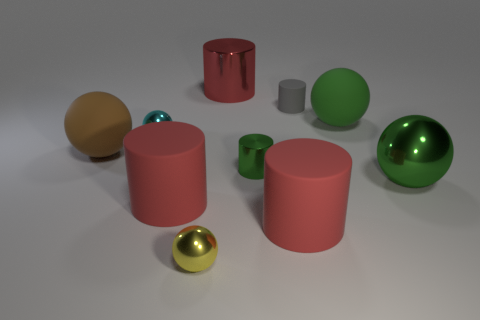How many cyan things are either tiny cylinders or metal balls?
Give a very brief answer. 1. Is the yellow shiny object the same shape as the tiny gray matte thing?
Offer a terse response. No. There is a large rubber cylinder that is to the left of the large red metal object; is there a cyan shiny object on the right side of it?
Offer a terse response. No. Are there an equal number of large brown rubber balls right of the tiny green object and spheres?
Make the answer very short. No. How many other objects are there of the same size as the cyan shiny ball?
Your answer should be very brief. 3. Are the big green ball that is in front of the cyan metal sphere and the small object that is in front of the large green metal object made of the same material?
Give a very brief answer. Yes. What size is the rubber ball that is on the right side of the red cylinder that is behind the big metal ball?
Offer a very short reply. Large. Is there a big metallic ball of the same color as the big shiny cylinder?
Give a very brief answer. No. Do the small ball right of the cyan object and the shiny sphere that is right of the small gray cylinder have the same color?
Give a very brief answer. No. The large green shiny thing is what shape?
Ensure brevity in your answer.  Sphere. 